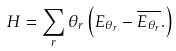Convert formula to latex. <formula><loc_0><loc_0><loc_500><loc_500>H = \sum _ { r } \theta _ { r } \left ( E _ { \theta _ { r } } - \overline { E _ { \theta _ { r } } } . \right )</formula> 